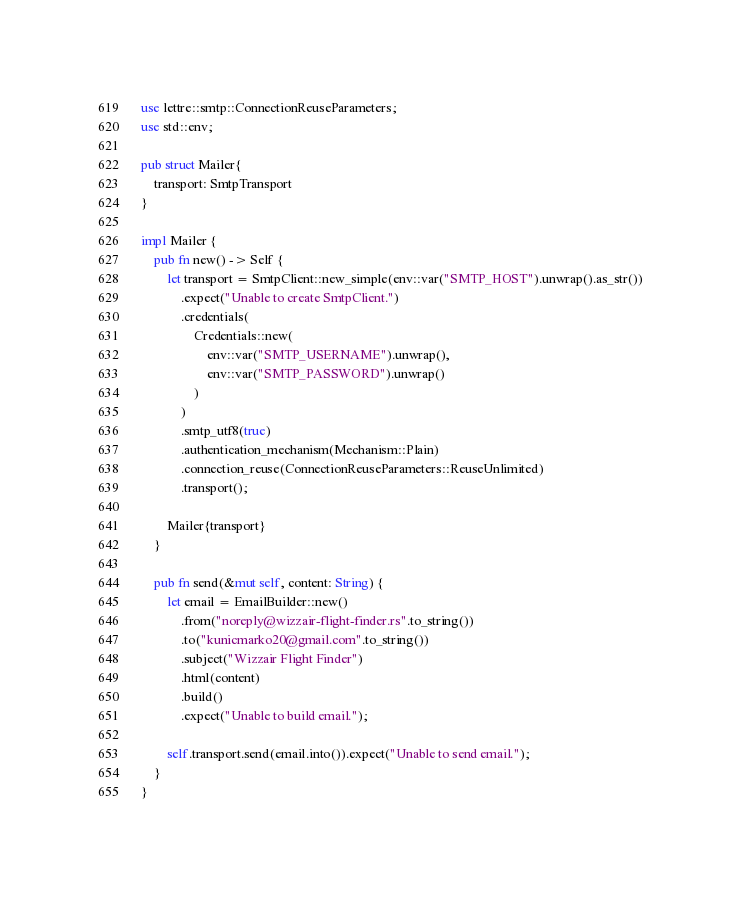Convert code to text. <code><loc_0><loc_0><loc_500><loc_500><_Rust_>use lettre::smtp::ConnectionReuseParameters;
use std::env;

pub struct Mailer{
    transport: SmtpTransport
}

impl Mailer {
    pub fn new() -> Self {
        let transport = SmtpClient::new_simple(env::var("SMTP_HOST").unwrap().as_str())
            .expect("Unable to create SmtpClient.")
            .credentials(
                Credentials::new(
                    env::var("SMTP_USERNAME").unwrap(),
                    env::var("SMTP_PASSWORD").unwrap()
                )
            )
            .smtp_utf8(true)
            .authentication_mechanism(Mechanism::Plain)
            .connection_reuse(ConnectionReuseParameters::ReuseUnlimited)
            .transport();

        Mailer{transport}
    }

    pub fn send(&mut self, content: String) {
        let email = EmailBuilder::new()
            .from("noreply@wizzair-flight-finder.rs".to_string())
            .to("kunicmarko20@gmail.com".to_string())
            .subject("Wizzair Flight Finder")
            .html(content)
            .build()
            .expect("Unable to build email.");

        self.transport.send(email.into()).expect("Unable to send email.");
    }
}</code> 